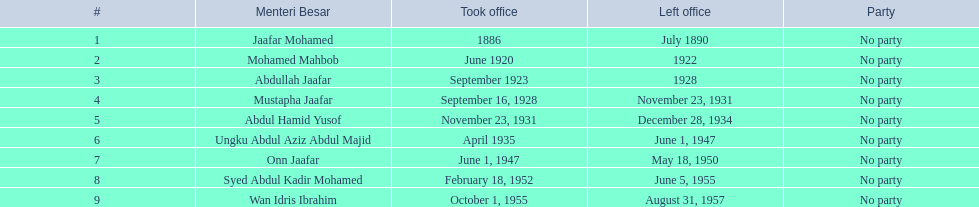When did jaafar mohamed assume office? 1886. When did mohamed mahbob begin his tenure? June 1920. Which individual held office for a maximum of 4 years? Mohamed Mahbob. 